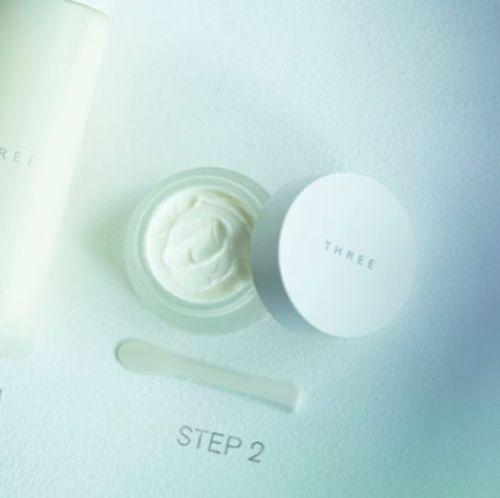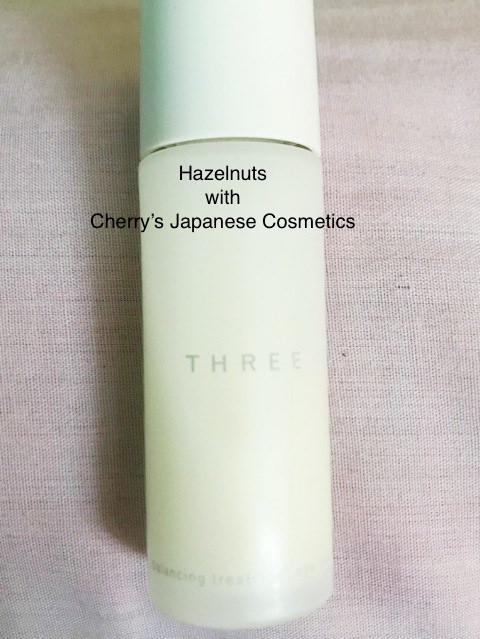The first image is the image on the left, the second image is the image on the right. Considering the images on both sides, is "Each container has a round shape." valid? Answer yes or no. Yes. 